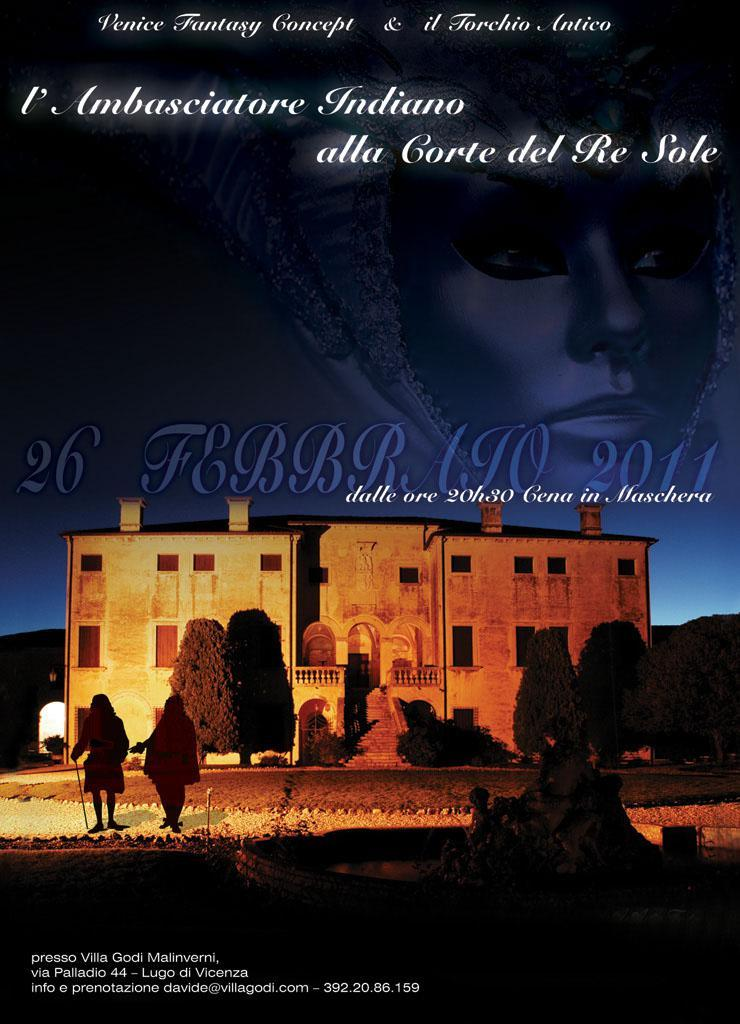What type of visual is the image in the poster? The image is an animated image. What other elements are present on the poster besides the animated image? The poster has texts. Can you describe the animated scene? In the animated image, there are persons, trees, a mountain, a building, and the sky is visible. How many structures are present in the animated image? There are two structures in the animated image: a mountain and a building. How many visitors are allowed in the jail depicted in the image? There is no jail depicted in the image; it features an animated scene with persons, trees, a mountain, a building, and the sky. 